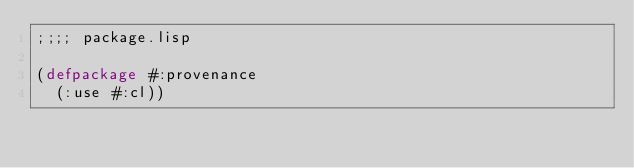Convert code to text. <code><loc_0><loc_0><loc_500><loc_500><_Lisp_>;;;; package.lisp

(defpackage #:provenance
  (:use #:cl))

</code> 